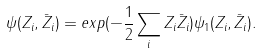<formula> <loc_0><loc_0><loc_500><loc_500>\psi ( Z _ { i } , \bar { Z } _ { i } ) = e x p ( - \frac { 1 } { 2 } \sum _ { i } Z _ { i } \bar { Z } _ { i } ) \psi _ { 1 } ( Z _ { i } , \bar { Z } _ { i } ) .</formula> 